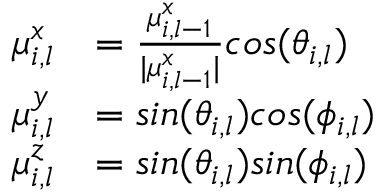Convert formula to latex. <formula><loc_0><loc_0><loc_500><loc_500>\begin{array} { r l } { \mu _ { i , l } ^ { x } } & { = \frac { \mu _ { i , l - 1 } ^ { x } } { | \mu _ { i , l - 1 } ^ { x } | } \cos ( \theta _ { i , l } ) } \\ { \mu _ { i , l } ^ { y } } & { = \sin ( \theta _ { i , l } ) \cos ( \phi _ { i , l } ) } \\ { \mu _ { i , l } ^ { z } } & { = \sin ( \theta _ { i , l } ) \sin ( \phi _ { i , l } ) } \end{array}</formula> 